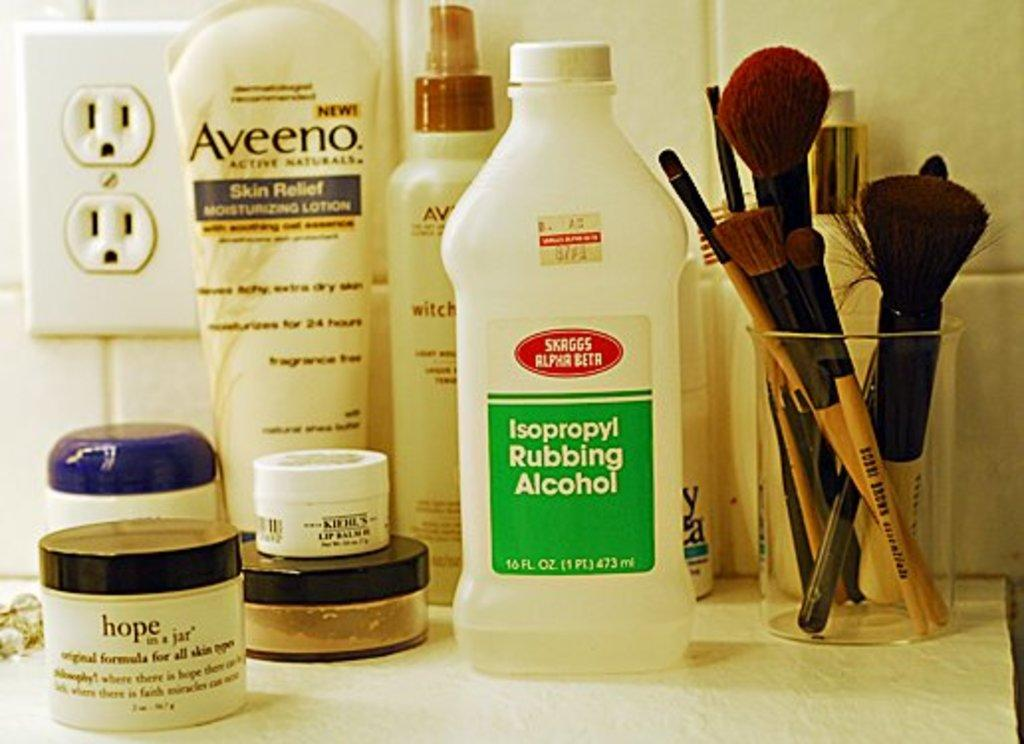<image>
Give a short and clear explanation of the subsequent image. different bottles of creams and makeup applicators including a bottle of rubbing alcohol. 